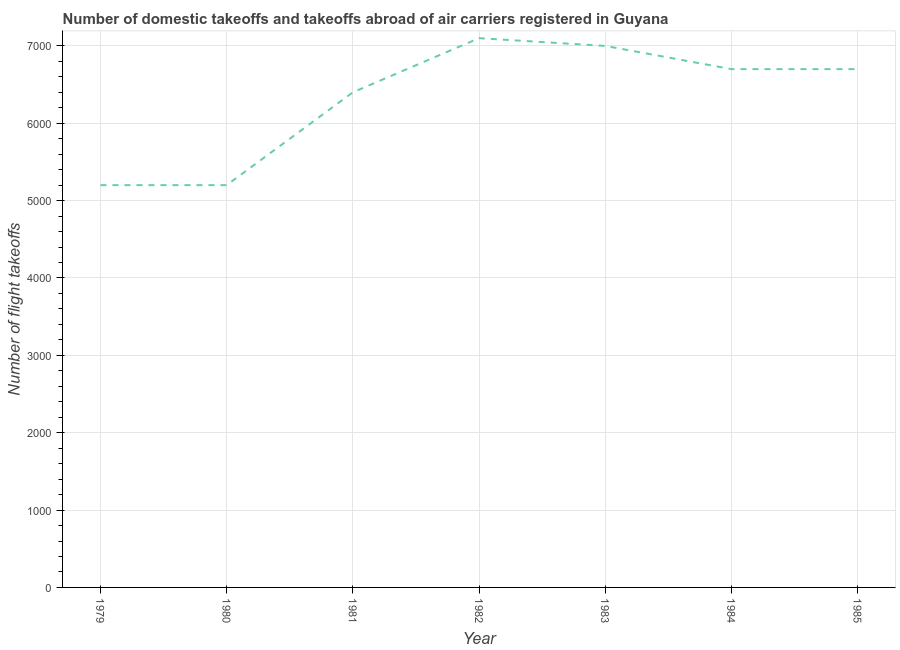What is the number of flight takeoffs in 1984?
Your answer should be very brief. 6700. Across all years, what is the maximum number of flight takeoffs?
Keep it short and to the point. 7100. Across all years, what is the minimum number of flight takeoffs?
Provide a short and direct response. 5200. In which year was the number of flight takeoffs maximum?
Your response must be concise. 1982. In which year was the number of flight takeoffs minimum?
Provide a succinct answer. 1979. What is the sum of the number of flight takeoffs?
Ensure brevity in your answer.  4.43e+04. What is the difference between the number of flight takeoffs in 1979 and 1983?
Give a very brief answer. -1800. What is the average number of flight takeoffs per year?
Offer a terse response. 6328.57. What is the median number of flight takeoffs?
Your answer should be compact. 6700. In how many years, is the number of flight takeoffs greater than 6400 ?
Make the answer very short. 4. What is the ratio of the number of flight takeoffs in 1983 to that in 1985?
Your answer should be compact. 1.04. What is the difference between the highest and the second highest number of flight takeoffs?
Provide a short and direct response. 100. What is the difference between the highest and the lowest number of flight takeoffs?
Keep it short and to the point. 1900. Does the number of flight takeoffs monotonically increase over the years?
Give a very brief answer. No. How many lines are there?
Make the answer very short. 1. What is the difference between two consecutive major ticks on the Y-axis?
Give a very brief answer. 1000. Does the graph contain any zero values?
Make the answer very short. No. What is the title of the graph?
Provide a short and direct response. Number of domestic takeoffs and takeoffs abroad of air carriers registered in Guyana. What is the label or title of the X-axis?
Give a very brief answer. Year. What is the label or title of the Y-axis?
Your answer should be very brief. Number of flight takeoffs. What is the Number of flight takeoffs in 1979?
Keep it short and to the point. 5200. What is the Number of flight takeoffs in 1980?
Offer a very short reply. 5200. What is the Number of flight takeoffs of 1981?
Keep it short and to the point. 6400. What is the Number of flight takeoffs in 1982?
Ensure brevity in your answer.  7100. What is the Number of flight takeoffs in 1983?
Your answer should be compact. 7000. What is the Number of flight takeoffs in 1984?
Your response must be concise. 6700. What is the Number of flight takeoffs in 1985?
Your response must be concise. 6700. What is the difference between the Number of flight takeoffs in 1979 and 1981?
Offer a terse response. -1200. What is the difference between the Number of flight takeoffs in 1979 and 1982?
Your response must be concise. -1900. What is the difference between the Number of flight takeoffs in 1979 and 1983?
Make the answer very short. -1800. What is the difference between the Number of flight takeoffs in 1979 and 1984?
Provide a short and direct response. -1500. What is the difference between the Number of flight takeoffs in 1979 and 1985?
Offer a terse response. -1500. What is the difference between the Number of flight takeoffs in 1980 and 1981?
Give a very brief answer. -1200. What is the difference between the Number of flight takeoffs in 1980 and 1982?
Provide a short and direct response. -1900. What is the difference between the Number of flight takeoffs in 1980 and 1983?
Offer a very short reply. -1800. What is the difference between the Number of flight takeoffs in 1980 and 1984?
Offer a very short reply. -1500. What is the difference between the Number of flight takeoffs in 1980 and 1985?
Ensure brevity in your answer.  -1500. What is the difference between the Number of flight takeoffs in 1981 and 1982?
Ensure brevity in your answer.  -700. What is the difference between the Number of flight takeoffs in 1981 and 1983?
Keep it short and to the point. -600. What is the difference between the Number of flight takeoffs in 1981 and 1984?
Provide a short and direct response. -300. What is the difference between the Number of flight takeoffs in 1981 and 1985?
Provide a succinct answer. -300. What is the difference between the Number of flight takeoffs in 1982 and 1983?
Ensure brevity in your answer.  100. What is the difference between the Number of flight takeoffs in 1982 and 1984?
Keep it short and to the point. 400. What is the difference between the Number of flight takeoffs in 1982 and 1985?
Provide a short and direct response. 400. What is the difference between the Number of flight takeoffs in 1983 and 1984?
Offer a very short reply. 300. What is the difference between the Number of flight takeoffs in 1983 and 1985?
Provide a short and direct response. 300. What is the difference between the Number of flight takeoffs in 1984 and 1985?
Make the answer very short. 0. What is the ratio of the Number of flight takeoffs in 1979 to that in 1980?
Your answer should be very brief. 1. What is the ratio of the Number of flight takeoffs in 1979 to that in 1981?
Give a very brief answer. 0.81. What is the ratio of the Number of flight takeoffs in 1979 to that in 1982?
Ensure brevity in your answer.  0.73. What is the ratio of the Number of flight takeoffs in 1979 to that in 1983?
Make the answer very short. 0.74. What is the ratio of the Number of flight takeoffs in 1979 to that in 1984?
Ensure brevity in your answer.  0.78. What is the ratio of the Number of flight takeoffs in 1979 to that in 1985?
Offer a very short reply. 0.78. What is the ratio of the Number of flight takeoffs in 1980 to that in 1981?
Ensure brevity in your answer.  0.81. What is the ratio of the Number of flight takeoffs in 1980 to that in 1982?
Provide a succinct answer. 0.73. What is the ratio of the Number of flight takeoffs in 1980 to that in 1983?
Your response must be concise. 0.74. What is the ratio of the Number of flight takeoffs in 1980 to that in 1984?
Provide a short and direct response. 0.78. What is the ratio of the Number of flight takeoffs in 1980 to that in 1985?
Keep it short and to the point. 0.78. What is the ratio of the Number of flight takeoffs in 1981 to that in 1982?
Your answer should be compact. 0.9. What is the ratio of the Number of flight takeoffs in 1981 to that in 1983?
Offer a terse response. 0.91. What is the ratio of the Number of flight takeoffs in 1981 to that in 1984?
Make the answer very short. 0.95. What is the ratio of the Number of flight takeoffs in 1981 to that in 1985?
Provide a short and direct response. 0.95. What is the ratio of the Number of flight takeoffs in 1982 to that in 1983?
Your response must be concise. 1.01. What is the ratio of the Number of flight takeoffs in 1982 to that in 1984?
Provide a succinct answer. 1.06. What is the ratio of the Number of flight takeoffs in 1982 to that in 1985?
Provide a short and direct response. 1.06. What is the ratio of the Number of flight takeoffs in 1983 to that in 1984?
Offer a terse response. 1.04. What is the ratio of the Number of flight takeoffs in 1983 to that in 1985?
Keep it short and to the point. 1.04. What is the ratio of the Number of flight takeoffs in 1984 to that in 1985?
Offer a terse response. 1. 